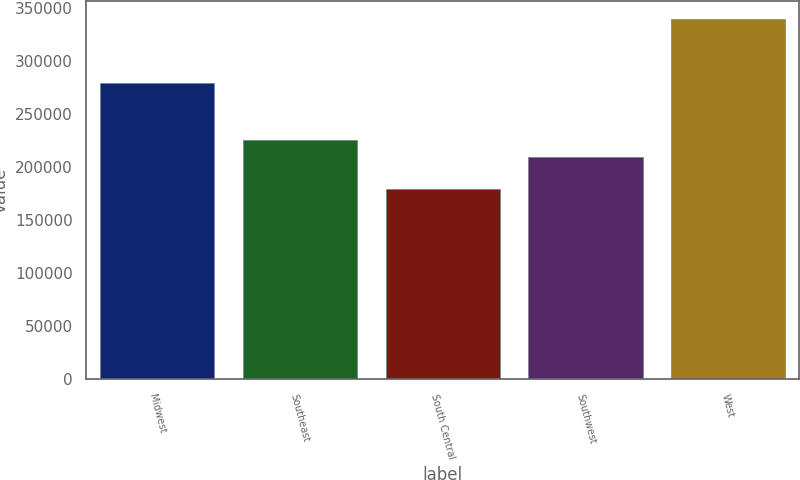Convert chart to OTSL. <chart><loc_0><loc_0><loc_500><loc_500><bar_chart><fcel>Midwest<fcel>Southeast<fcel>South Central<fcel>Southwest<fcel>West<nl><fcel>279300<fcel>226120<fcel>179800<fcel>210100<fcel>340000<nl></chart> 